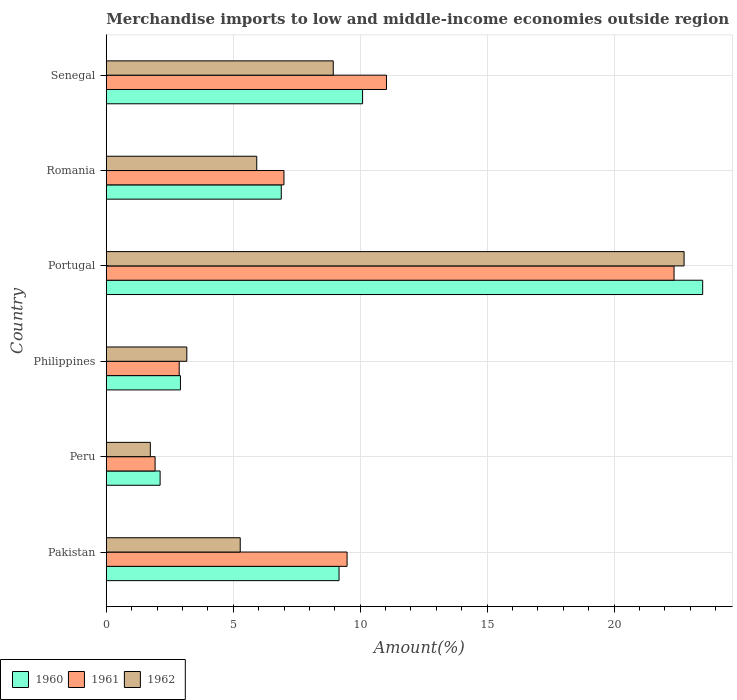Are the number of bars per tick equal to the number of legend labels?
Your answer should be compact. Yes. How many bars are there on the 6th tick from the bottom?
Your answer should be very brief. 3. What is the label of the 5th group of bars from the top?
Provide a succinct answer. Peru. What is the percentage of amount earned from merchandise imports in 1961 in Philippines?
Offer a very short reply. 2.87. Across all countries, what is the maximum percentage of amount earned from merchandise imports in 1962?
Your answer should be very brief. 22.76. Across all countries, what is the minimum percentage of amount earned from merchandise imports in 1960?
Provide a succinct answer. 2.12. In which country was the percentage of amount earned from merchandise imports in 1960 maximum?
Provide a short and direct response. Portugal. What is the total percentage of amount earned from merchandise imports in 1960 in the graph?
Your answer should be very brief. 54.67. What is the difference between the percentage of amount earned from merchandise imports in 1962 in Pakistan and that in Romania?
Give a very brief answer. -0.65. What is the difference between the percentage of amount earned from merchandise imports in 1960 in Peru and the percentage of amount earned from merchandise imports in 1962 in Portugal?
Provide a short and direct response. -20.64. What is the average percentage of amount earned from merchandise imports in 1960 per country?
Offer a terse response. 9.11. What is the difference between the percentage of amount earned from merchandise imports in 1960 and percentage of amount earned from merchandise imports in 1962 in Philippines?
Your answer should be very brief. -0.25. In how many countries, is the percentage of amount earned from merchandise imports in 1961 greater than 1 %?
Your answer should be very brief. 6. What is the ratio of the percentage of amount earned from merchandise imports in 1961 in Philippines to that in Portugal?
Give a very brief answer. 0.13. What is the difference between the highest and the second highest percentage of amount earned from merchandise imports in 1962?
Provide a short and direct response. 13.82. What is the difference between the highest and the lowest percentage of amount earned from merchandise imports in 1960?
Keep it short and to the point. 21.37. In how many countries, is the percentage of amount earned from merchandise imports in 1960 greater than the average percentage of amount earned from merchandise imports in 1960 taken over all countries?
Provide a short and direct response. 3. Is it the case that in every country, the sum of the percentage of amount earned from merchandise imports in 1960 and percentage of amount earned from merchandise imports in 1962 is greater than the percentage of amount earned from merchandise imports in 1961?
Your answer should be very brief. Yes. Are all the bars in the graph horizontal?
Provide a short and direct response. Yes. What is the difference between two consecutive major ticks on the X-axis?
Make the answer very short. 5. Are the values on the major ticks of X-axis written in scientific E-notation?
Make the answer very short. No. Where does the legend appear in the graph?
Keep it short and to the point. Bottom left. How many legend labels are there?
Offer a very short reply. 3. What is the title of the graph?
Provide a short and direct response. Merchandise imports to low and middle-income economies outside region. What is the label or title of the X-axis?
Offer a very short reply. Amount(%). What is the label or title of the Y-axis?
Keep it short and to the point. Country. What is the Amount(%) in 1960 in Pakistan?
Ensure brevity in your answer.  9.17. What is the Amount(%) in 1961 in Pakistan?
Ensure brevity in your answer.  9.48. What is the Amount(%) in 1962 in Pakistan?
Make the answer very short. 5.27. What is the Amount(%) in 1960 in Peru?
Provide a short and direct response. 2.12. What is the Amount(%) of 1961 in Peru?
Keep it short and to the point. 1.92. What is the Amount(%) of 1962 in Peru?
Give a very brief answer. 1.73. What is the Amount(%) in 1960 in Philippines?
Your answer should be very brief. 2.92. What is the Amount(%) of 1961 in Philippines?
Provide a short and direct response. 2.87. What is the Amount(%) of 1962 in Philippines?
Make the answer very short. 3.17. What is the Amount(%) in 1960 in Portugal?
Give a very brief answer. 23.49. What is the Amount(%) of 1961 in Portugal?
Offer a very short reply. 22.36. What is the Amount(%) in 1962 in Portugal?
Offer a very short reply. 22.76. What is the Amount(%) of 1960 in Romania?
Make the answer very short. 6.89. What is the Amount(%) in 1961 in Romania?
Your answer should be compact. 7. What is the Amount(%) of 1962 in Romania?
Offer a terse response. 5.92. What is the Amount(%) in 1960 in Senegal?
Offer a very short reply. 10.09. What is the Amount(%) in 1961 in Senegal?
Ensure brevity in your answer.  11.03. What is the Amount(%) in 1962 in Senegal?
Keep it short and to the point. 8.94. Across all countries, what is the maximum Amount(%) in 1960?
Ensure brevity in your answer.  23.49. Across all countries, what is the maximum Amount(%) of 1961?
Offer a terse response. 22.36. Across all countries, what is the maximum Amount(%) in 1962?
Provide a succinct answer. 22.76. Across all countries, what is the minimum Amount(%) of 1960?
Your answer should be compact. 2.12. Across all countries, what is the minimum Amount(%) in 1961?
Keep it short and to the point. 1.92. Across all countries, what is the minimum Amount(%) in 1962?
Give a very brief answer. 1.73. What is the total Amount(%) of 1960 in the graph?
Your response must be concise. 54.67. What is the total Amount(%) of 1961 in the graph?
Offer a very short reply. 54.67. What is the total Amount(%) of 1962 in the graph?
Your response must be concise. 47.8. What is the difference between the Amount(%) of 1960 in Pakistan and that in Peru?
Your response must be concise. 7.05. What is the difference between the Amount(%) in 1961 in Pakistan and that in Peru?
Provide a short and direct response. 7.56. What is the difference between the Amount(%) of 1962 in Pakistan and that in Peru?
Your answer should be compact. 3.54. What is the difference between the Amount(%) in 1960 in Pakistan and that in Philippines?
Your answer should be very brief. 6.25. What is the difference between the Amount(%) in 1961 in Pakistan and that in Philippines?
Keep it short and to the point. 6.61. What is the difference between the Amount(%) in 1962 in Pakistan and that in Philippines?
Your response must be concise. 2.1. What is the difference between the Amount(%) of 1960 in Pakistan and that in Portugal?
Offer a very short reply. -14.32. What is the difference between the Amount(%) of 1961 in Pakistan and that in Portugal?
Your answer should be very brief. -12.88. What is the difference between the Amount(%) in 1962 in Pakistan and that in Portugal?
Your answer should be compact. -17.48. What is the difference between the Amount(%) in 1960 in Pakistan and that in Romania?
Offer a terse response. 2.28. What is the difference between the Amount(%) of 1961 in Pakistan and that in Romania?
Keep it short and to the point. 2.49. What is the difference between the Amount(%) of 1962 in Pakistan and that in Romania?
Offer a very short reply. -0.65. What is the difference between the Amount(%) of 1960 in Pakistan and that in Senegal?
Provide a succinct answer. -0.93. What is the difference between the Amount(%) in 1961 in Pakistan and that in Senegal?
Your answer should be very brief. -1.55. What is the difference between the Amount(%) of 1962 in Pakistan and that in Senegal?
Provide a short and direct response. -3.66. What is the difference between the Amount(%) in 1960 in Peru and that in Philippines?
Offer a terse response. -0.8. What is the difference between the Amount(%) in 1961 in Peru and that in Philippines?
Your answer should be very brief. -0.95. What is the difference between the Amount(%) of 1962 in Peru and that in Philippines?
Offer a terse response. -1.44. What is the difference between the Amount(%) of 1960 in Peru and that in Portugal?
Provide a short and direct response. -21.37. What is the difference between the Amount(%) of 1961 in Peru and that in Portugal?
Your answer should be compact. -20.44. What is the difference between the Amount(%) of 1962 in Peru and that in Portugal?
Your answer should be compact. -21.02. What is the difference between the Amount(%) of 1960 in Peru and that in Romania?
Keep it short and to the point. -4.77. What is the difference between the Amount(%) in 1961 in Peru and that in Romania?
Provide a succinct answer. -5.08. What is the difference between the Amount(%) in 1962 in Peru and that in Romania?
Offer a terse response. -4.19. What is the difference between the Amount(%) of 1960 in Peru and that in Senegal?
Keep it short and to the point. -7.97. What is the difference between the Amount(%) in 1961 in Peru and that in Senegal?
Make the answer very short. -9.11. What is the difference between the Amount(%) of 1962 in Peru and that in Senegal?
Provide a succinct answer. -7.21. What is the difference between the Amount(%) of 1960 in Philippines and that in Portugal?
Keep it short and to the point. -20.57. What is the difference between the Amount(%) of 1961 in Philippines and that in Portugal?
Your answer should be very brief. -19.49. What is the difference between the Amount(%) of 1962 in Philippines and that in Portugal?
Offer a terse response. -19.59. What is the difference between the Amount(%) of 1960 in Philippines and that in Romania?
Give a very brief answer. -3.97. What is the difference between the Amount(%) of 1961 in Philippines and that in Romania?
Your answer should be compact. -4.13. What is the difference between the Amount(%) in 1962 in Philippines and that in Romania?
Your answer should be compact. -2.75. What is the difference between the Amount(%) of 1960 in Philippines and that in Senegal?
Make the answer very short. -7.17. What is the difference between the Amount(%) in 1961 in Philippines and that in Senegal?
Your response must be concise. -8.16. What is the difference between the Amount(%) of 1962 in Philippines and that in Senegal?
Your answer should be compact. -5.77. What is the difference between the Amount(%) in 1960 in Portugal and that in Romania?
Provide a short and direct response. 16.6. What is the difference between the Amount(%) of 1961 in Portugal and that in Romania?
Ensure brevity in your answer.  15.36. What is the difference between the Amount(%) in 1962 in Portugal and that in Romania?
Provide a succinct answer. 16.83. What is the difference between the Amount(%) in 1960 in Portugal and that in Senegal?
Your answer should be compact. 13.4. What is the difference between the Amount(%) of 1961 in Portugal and that in Senegal?
Provide a succinct answer. 11.33. What is the difference between the Amount(%) of 1962 in Portugal and that in Senegal?
Your answer should be very brief. 13.82. What is the difference between the Amount(%) in 1960 in Romania and that in Senegal?
Ensure brevity in your answer.  -3.2. What is the difference between the Amount(%) in 1961 in Romania and that in Senegal?
Offer a terse response. -4.04. What is the difference between the Amount(%) of 1962 in Romania and that in Senegal?
Provide a short and direct response. -3.01. What is the difference between the Amount(%) in 1960 in Pakistan and the Amount(%) in 1961 in Peru?
Offer a terse response. 7.25. What is the difference between the Amount(%) in 1960 in Pakistan and the Amount(%) in 1962 in Peru?
Offer a terse response. 7.43. What is the difference between the Amount(%) of 1961 in Pakistan and the Amount(%) of 1962 in Peru?
Your answer should be compact. 7.75. What is the difference between the Amount(%) in 1960 in Pakistan and the Amount(%) in 1961 in Philippines?
Offer a terse response. 6.3. What is the difference between the Amount(%) in 1960 in Pakistan and the Amount(%) in 1962 in Philippines?
Ensure brevity in your answer.  6. What is the difference between the Amount(%) in 1961 in Pakistan and the Amount(%) in 1962 in Philippines?
Offer a very short reply. 6.31. What is the difference between the Amount(%) of 1960 in Pakistan and the Amount(%) of 1961 in Portugal?
Provide a succinct answer. -13.2. What is the difference between the Amount(%) of 1960 in Pakistan and the Amount(%) of 1962 in Portugal?
Your answer should be very brief. -13.59. What is the difference between the Amount(%) in 1961 in Pakistan and the Amount(%) in 1962 in Portugal?
Your answer should be very brief. -13.27. What is the difference between the Amount(%) of 1960 in Pakistan and the Amount(%) of 1961 in Romania?
Make the answer very short. 2.17. What is the difference between the Amount(%) of 1960 in Pakistan and the Amount(%) of 1962 in Romania?
Your answer should be very brief. 3.24. What is the difference between the Amount(%) of 1961 in Pakistan and the Amount(%) of 1962 in Romania?
Your response must be concise. 3.56. What is the difference between the Amount(%) of 1960 in Pakistan and the Amount(%) of 1961 in Senegal?
Your response must be concise. -1.87. What is the difference between the Amount(%) in 1960 in Pakistan and the Amount(%) in 1962 in Senegal?
Provide a succinct answer. 0.23. What is the difference between the Amount(%) in 1961 in Pakistan and the Amount(%) in 1962 in Senegal?
Offer a very short reply. 0.54. What is the difference between the Amount(%) of 1960 in Peru and the Amount(%) of 1961 in Philippines?
Keep it short and to the point. -0.75. What is the difference between the Amount(%) of 1960 in Peru and the Amount(%) of 1962 in Philippines?
Offer a very short reply. -1.05. What is the difference between the Amount(%) of 1961 in Peru and the Amount(%) of 1962 in Philippines?
Offer a terse response. -1.25. What is the difference between the Amount(%) of 1960 in Peru and the Amount(%) of 1961 in Portugal?
Provide a short and direct response. -20.24. What is the difference between the Amount(%) in 1960 in Peru and the Amount(%) in 1962 in Portugal?
Offer a terse response. -20.64. What is the difference between the Amount(%) in 1961 in Peru and the Amount(%) in 1962 in Portugal?
Make the answer very short. -20.84. What is the difference between the Amount(%) of 1960 in Peru and the Amount(%) of 1961 in Romania?
Keep it short and to the point. -4.88. What is the difference between the Amount(%) of 1960 in Peru and the Amount(%) of 1962 in Romania?
Offer a terse response. -3.81. What is the difference between the Amount(%) in 1961 in Peru and the Amount(%) in 1962 in Romania?
Ensure brevity in your answer.  -4. What is the difference between the Amount(%) of 1960 in Peru and the Amount(%) of 1961 in Senegal?
Keep it short and to the point. -8.92. What is the difference between the Amount(%) of 1960 in Peru and the Amount(%) of 1962 in Senegal?
Make the answer very short. -6.82. What is the difference between the Amount(%) in 1961 in Peru and the Amount(%) in 1962 in Senegal?
Offer a very short reply. -7.02. What is the difference between the Amount(%) of 1960 in Philippines and the Amount(%) of 1961 in Portugal?
Give a very brief answer. -19.44. What is the difference between the Amount(%) of 1960 in Philippines and the Amount(%) of 1962 in Portugal?
Offer a terse response. -19.84. What is the difference between the Amount(%) of 1961 in Philippines and the Amount(%) of 1962 in Portugal?
Offer a terse response. -19.89. What is the difference between the Amount(%) in 1960 in Philippines and the Amount(%) in 1961 in Romania?
Your answer should be very brief. -4.08. What is the difference between the Amount(%) in 1960 in Philippines and the Amount(%) in 1962 in Romania?
Provide a succinct answer. -3.01. What is the difference between the Amount(%) in 1961 in Philippines and the Amount(%) in 1962 in Romania?
Your response must be concise. -3.05. What is the difference between the Amount(%) in 1960 in Philippines and the Amount(%) in 1961 in Senegal?
Keep it short and to the point. -8.12. What is the difference between the Amount(%) of 1960 in Philippines and the Amount(%) of 1962 in Senegal?
Make the answer very short. -6.02. What is the difference between the Amount(%) in 1961 in Philippines and the Amount(%) in 1962 in Senegal?
Provide a short and direct response. -6.07. What is the difference between the Amount(%) of 1960 in Portugal and the Amount(%) of 1961 in Romania?
Your response must be concise. 16.49. What is the difference between the Amount(%) of 1960 in Portugal and the Amount(%) of 1962 in Romania?
Your response must be concise. 17.56. What is the difference between the Amount(%) in 1961 in Portugal and the Amount(%) in 1962 in Romania?
Make the answer very short. 16.44. What is the difference between the Amount(%) of 1960 in Portugal and the Amount(%) of 1961 in Senegal?
Provide a short and direct response. 12.45. What is the difference between the Amount(%) of 1960 in Portugal and the Amount(%) of 1962 in Senegal?
Offer a very short reply. 14.55. What is the difference between the Amount(%) in 1961 in Portugal and the Amount(%) in 1962 in Senegal?
Provide a short and direct response. 13.42. What is the difference between the Amount(%) of 1960 in Romania and the Amount(%) of 1961 in Senegal?
Your answer should be compact. -4.14. What is the difference between the Amount(%) in 1960 in Romania and the Amount(%) in 1962 in Senegal?
Your answer should be compact. -2.05. What is the difference between the Amount(%) in 1961 in Romania and the Amount(%) in 1962 in Senegal?
Keep it short and to the point. -1.94. What is the average Amount(%) of 1960 per country?
Your response must be concise. 9.11. What is the average Amount(%) of 1961 per country?
Your answer should be very brief. 9.11. What is the average Amount(%) in 1962 per country?
Make the answer very short. 7.97. What is the difference between the Amount(%) of 1960 and Amount(%) of 1961 in Pakistan?
Your answer should be very brief. -0.32. What is the difference between the Amount(%) of 1960 and Amount(%) of 1962 in Pakistan?
Your response must be concise. 3.89. What is the difference between the Amount(%) of 1961 and Amount(%) of 1962 in Pakistan?
Your answer should be compact. 4.21. What is the difference between the Amount(%) of 1960 and Amount(%) of 1961 in Peru?
Provide a succinct answer. 0.2. What is the difference between the Amount(%) of 1960 and Amount(%) of 1962 in Peru?
Provide a short and direct response. 0.39. What is the difference between the Amount(%) of 1961 and Amount(%) of 1962 in Peru?
Make the answer very short. 0.19. What is the difference between the Amount(%) in 1960 and Amount(%) in 1961 in Philippines?
Give a very brief answer. 0.05. What is the difference between the Amount(%) in 1960 and Amount(%) in 1962 in Philippines?
Provide a short and direct response. -0.25. What is the difference between the Amount(%) of 1961 and Amount(%) of 1962 in Philippines?
Ensure brevity in your answer.  -0.3. What is the difference between the Amount(%) of 1960 and Amount(%) of 1961 in Portugal?
Keep it short and to the point. 1.13. What is the difference between the Amount(%) of 1960 and Amount(%) of 1962 in Portugal?
Keep it short and to the point. 0.73. What is the difference between the Amount(%) in 1961 and Amount(%) in 1962 in Portugal?
Your response must be concise. -0.39. What is the difference between the Amount(%) in 1960 and Amount(%) in 1961 in Romania?
Your response must be concise. -0.11. What is the difference between the Amount(%) of 1960 and Amount(%) of 1962 in Romania?
Your response must be concise. 0.97. What is the difference between the Amount(%) in 1961 and Amount(%) in 1962 in Romania?
Your answer should be compact. 1.07. What is the difference between the Amount(%) of 1960 and Amount(%) of 1961 in Senegal?
Your response must be concise. -0.94. What is the difference between the Amount(%) of 1960 and Amount(%) of 1962 in Senegal?
Make the answer very short. 1.16. What is the difference between the Amount(%) of 1961 and Amount(%) of 1962 in Senegal?
Keep it short and to the point. 2.1. What is the ratio of the Amount(%) of 1960 in Pakistan to that in Peru?
Offer a very short reply. 4.33. What is the ratio of the Amount(%) of 1961 in Pakistan to that in Peru?
Offer a very short reply. 4.94. What is the ratio of the Amount(%) of 1962 in Pakistan to that in Peru?
Give a very brief answer. 3.04. What is the ratio of the Amount(%) in 1960 in Pakistan to that in Philippines?
Make the answer very short. 3.14. What is the ratio of the Amount(%) in 1961 in Pakistan to that in Philippines?
Offer a very short reply. 3.3. What is the ratio of the Amount(%) in 1962 in Pakistan to that in Philippines?
Make the answer very short. 1.66. What is the ratio of the Amount(%) in 1960 in Pakistan to that in Portugal?
Ensure brevity in your answer.  0.39. What is the ratio of the Amount(%) in 1961 in Pakistan to that in Portugal?
Provide a succinct answer. 0.42. What is the ratio of the Amount(%) of 1962 in Pakistan to that in Portugal?
Provide a short and direct response. 0.23. What is the ratio of the Amount(%) in 1960 in Pakistan to that in Romania?
Make the answer very short. 1.33. What is the ratio of the Amount(%) in 1961 in Pakistan to that in Romania?
Offer a very short reply. 1.36. What is the ratio of the Amount(%) in 1962 in Pakistan to that in Romania?
Keep it short and to the point. 0.89. What is the ratio of the Amount(%) in 1960 in Pakistan to that in Senegal?
Offer a terse response. 0.91. What is the ratio of the Amount(%) of 1961 in Pakistan to that in Senegal?
Offer a very short reply. 0.86. What is the ratio of the Amount(%) in 1962 in Pakistan to that in Senegal?
Give a very brief answer. 0.59. What is the ratio of the Amount(%) in 1960 in Peru to that in Philippines?
Offer a terse response. 0.73. What is the ratio of the Amount(%) in 1961 in Peru to that in Philippines?
Make the answer very short. 0.67. What is the ratio of the Amount(%) in 1962 in Peru to that in Philippines?
Give a very brief answer. 0.55. What is the ratio of the Amount(%) of 1960 in Peru to that in Portugal?
Offer a terse response. 0.09. What is the ratio of the Amount(%) in 1961 in Peru to that in Portugal?
Your answer should be very brief. 0.09. What is the ratio of the Amount(%) in 1962 in Peru to that in Portugal?
Ensure brevity in your answer.  0.08. What is the ratio of the Amount(%) in 1960 in Peru to that in Romania?
Offer a terse response. 0.31. What is the ratio of the Amount(%) in 1961 in Peru to that in Romania?
Your response must be concise. 0.27. What is the ratio of the Amount(%) of 1962 in Peru to that in Romania?
Your response must be concise. 0.29. What is the ratio of the Amount(%) in 1960 in Peru to that in Senegal?
Give a very brief answer. 0.21. What is the ratio of the Amount(%) in 1961 in Peru to that in Senegal?
Your answer should be very brief. 0.17. What is the ratio of the Amount(%) of 1962 in Peru to that in Senegal?
Keep it short and to the point. 0.19. What is the ratio of the Amount(%) in 1960 in Philippines to that in Portugal?
Ensure brevity in your answer.  0.12. What is the ratio of the Amount(%) of 1961 in Philippines to that in Portugal?
Offer a very short reply. 0.13. What is the ratio of the Amount(%) of 1962 in Philippines to that in Portugal?
Offer a terse response. 0.14. What is the ratio of the Amount(%) of 1960 in Philippines to that in Romania?
Give a very brief answer. 0.42. What is the ratio of the Amount(%) of 1961 in Philippines to that in Romania?
Your response must be concise. 0.41. What is the ratio of the Amount(%) of 1962 in Philippines to that in Romania?
Ensure brevity in your answer.  0.54. What is the ratio of the Amount(%) in 1960 in Philippines to that in Senegal?
Provide a short and direct response. 0.29. What is the ratio of the Amount(%) in 1961 in Philippines to that in Senegal?
Your response must be concise. 0.26. What is the ratio of the Amount(%) of 1962 in Philippines to that in Senegal?
Make the answer very short. 0.35. What is the ratio of the Amount(%) in 1960 in Portugal to that in Romania?
Your answer should be very brief. 3.41. What is the ratio of the Amount(%) in 1961 in Portugal to that in Romania?
Offer a terse response. 3.2. What is the ratio of the Amount(%) in 1962 in Portugal to that in Romania?
Make the answer very short. 3.84. What is the ratio of the Amount(%) of 1960 in Portugal to that in Senegal?
Your answer should be compact. 2.33. What is the ratio of the Amount(%) in 1961 in Portugal to that in Senegal?
Keep it short and to the point. 2.03. What is the ratio of the Amount(%) in 1962 in Portugal to that in Senegal?
Ensure brevity in your answer.  2.55. What is the ratio of the Amount(%) of 1960 in Romania to that in Senegal?
Keep it short and to the point. 0.68. What is the ratio of the Amount(%) in 1961 in Romania to that in Senegal?
Provide a short and direct response. 0.63. What is the ratio of the Amount(%) of 1962 in Romania to that in Senegal?
Give a very brief answer. 0.66. What is the difference between the highest and the second highest Amount(%) in 1960?
Ensure brevity in your answer.  13.4. What is the difference between the highest and the second highest Amount(%) in 1961?
Your answer should be compact. 11.33. What is the difference between the highest and the second highest Amount(%) of 1962?
Offer a very short reply. 13.82. What is the difference between the highest and the lowest Amount(%) of 1960?
Offer a very short reply. 21.37. What is the difference between the highest and the lowest Amount(%) of 1961?
Your answer should be compact. 20.44. What is the difference between the highest and the lowest Amount(%) of 1962?
Offer a terse response. 21.02. 